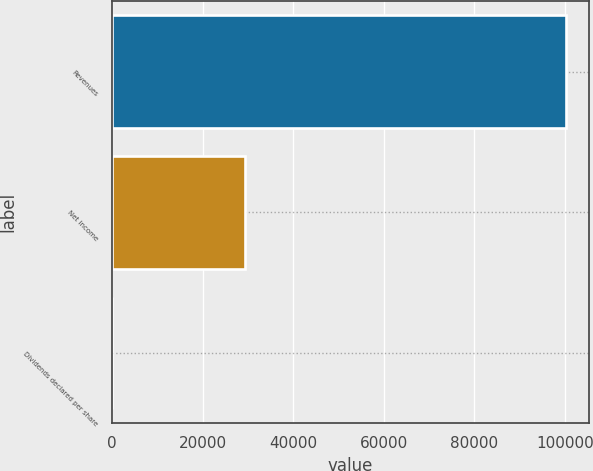Convert chart. <chart><loc_0><loc_0><loc_500><loc_500><bar_chart><fcel>Revenues<fcel>Net income<fcel>Dividends declared per share<nl><fcel>100306<fcel>29258<fcel>0.4<nl></chart> 